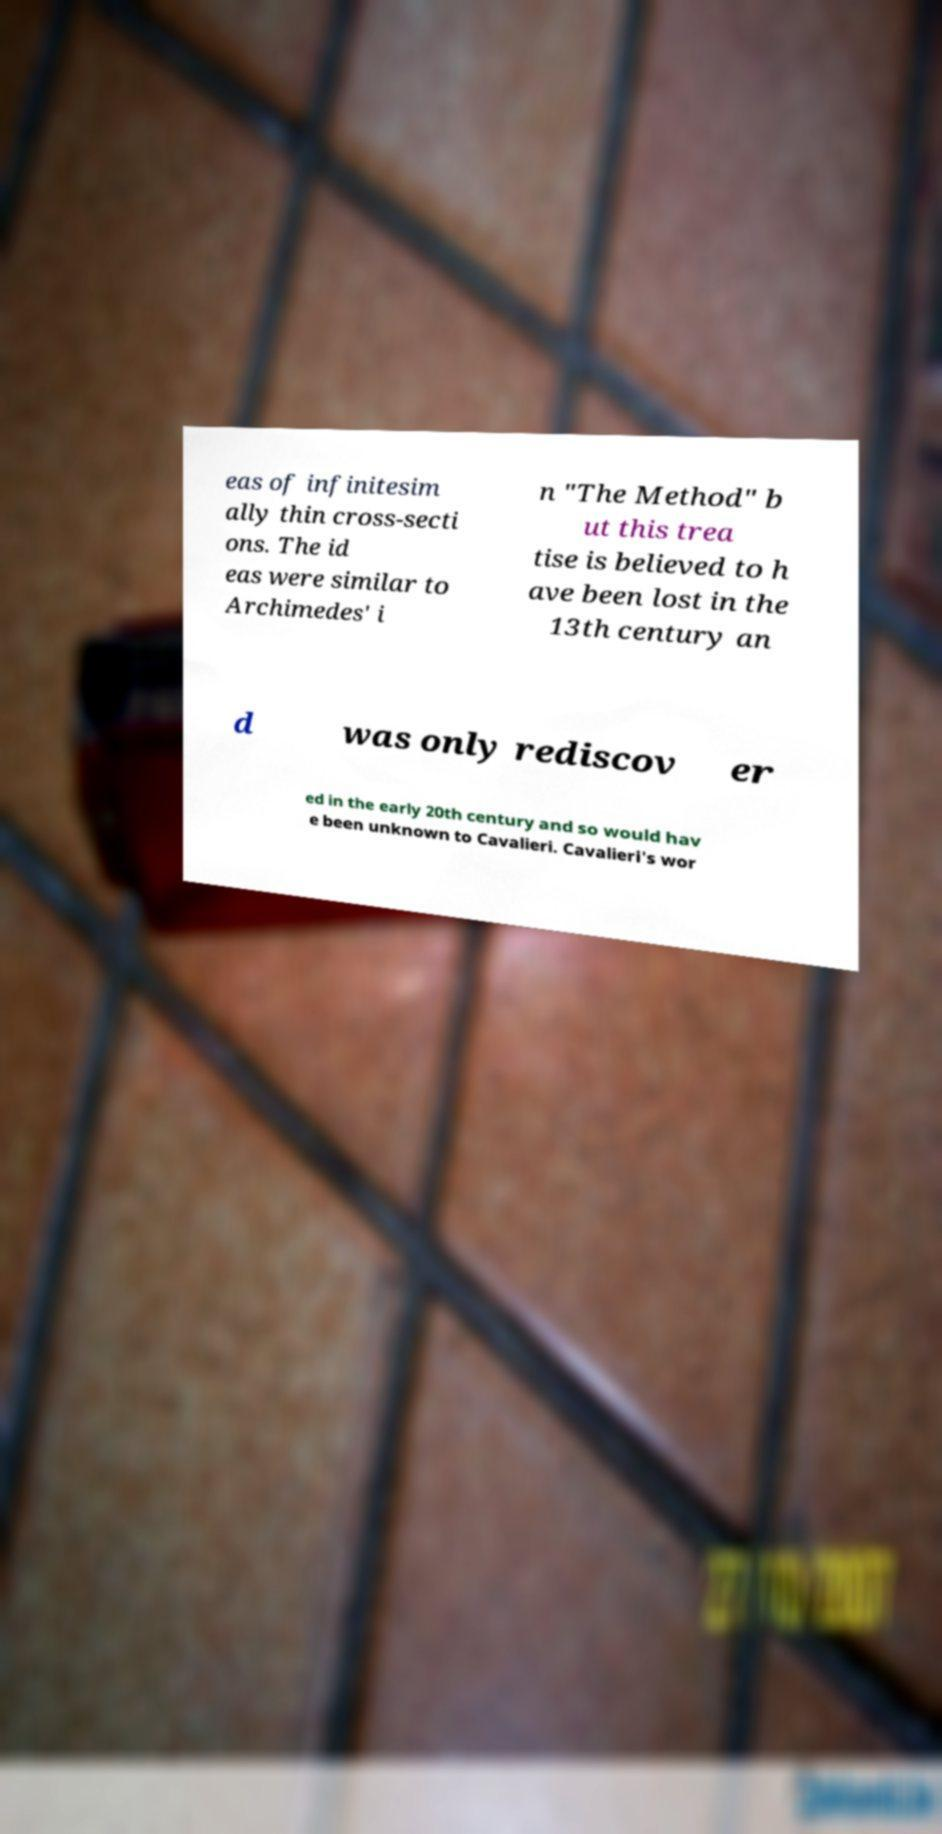What messages or text are displayed in this image? I need them in a readable, typed format. eas of infinitesim ally thin cross-secti ons. The id eas were similar to Archimedes' i n "The Method" b ut this trea tise is believed to h ave been lost in the 13th century an d was only rediscov er ed in the early 20th century and so would hav e been unknown to Cavalieri. Cavalieri's wor 